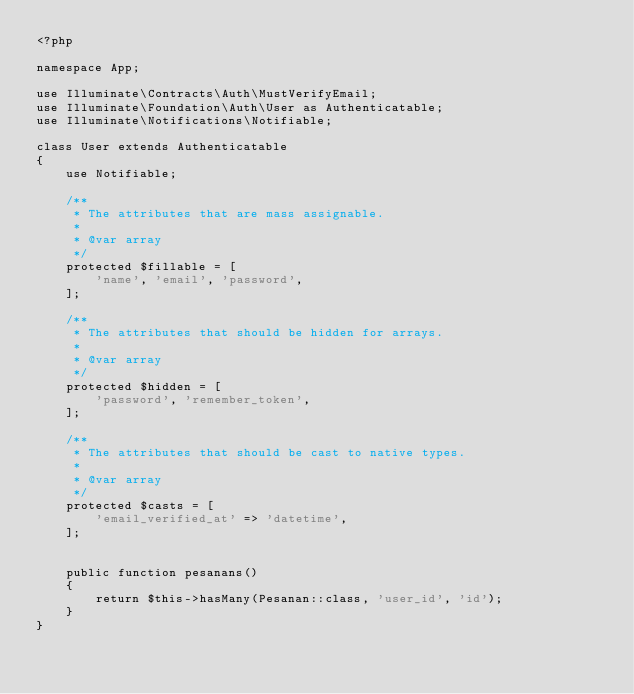Convert code to text. <code><loc_0><loc_0><loc_500><loc_500><_PHP_><?php

namespace App;

use Illuminate\Contracts\Auth\MustVerifyEmail;
use Illuminate\Foundation\Auth\User as Authenticatable;
use Illuminate\Notifications\Notifiable;

class User extends Authenticatable
{
    use Notifiable;

    /**
     * The attributes that are mass assignable.
     *
     * @var array
     */
    protected $fillable = [
        'name', 'email', 'password',
    ];

    /**
     * The attributes that should be hidden for arrays.
     *
     * @var array
     */
    protected $hidden = [
        'password', 'remember_token',
    ];

    /**
     * The attributes that should be cast to native types.
     *
     * @var array
     */
    protected $casts = [
        'email_verified_at' => 'datetime',
    ];

    
    public function pesanans()
    {
        return $this->hasMany(Pesanan::class, 'user_id', 'id');
    }
}
</code> 